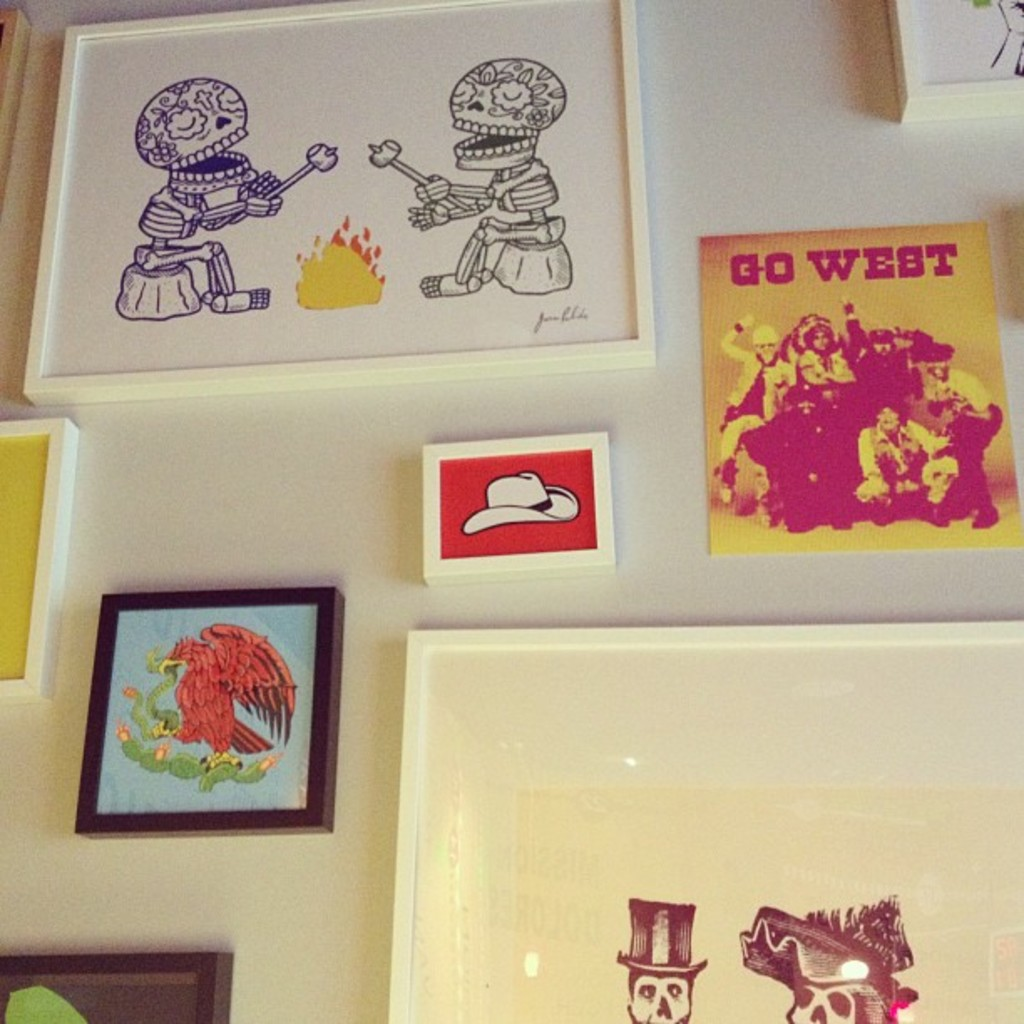What themes do you think are explored in the artworks displayed in the image? The artworks delve into themes of the Wild West and mortality, as evident from the 'GO WEST' piece reflecting adventure and perhaps migration, and the skeletal figures which could symbolize the transient nature of life, all depicted through a pop art style. 